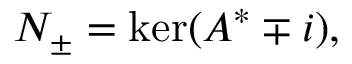<formula> <loc_0><loc_0><loc_500><loc_500>N _ { \pm } = \ker ( A ^ { * } \mp i ) ,</formula> 